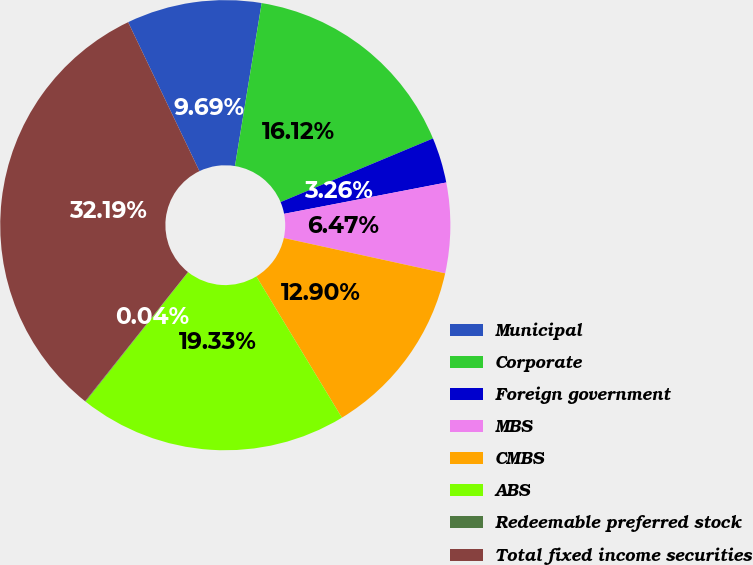Convert chart to OTSL. <chart><loc_0><loc_0><loc_500><loc_500><pie_chart><fcel>Municipal<fcel>Corporate<fcel>Foreign government<fcel>MBS<fcel>CMBS<fcel>ABS<fcel>Redeemable preferred stock<fcel>Total fixed income securities<nl><fcel>9.69%<fcel>16.12%<fcel>3.26%<fcel>6.47%<fcel>12.9%<fcel>19.33%<fcel>0.04%<fcel>32.19%<nl></chart> 